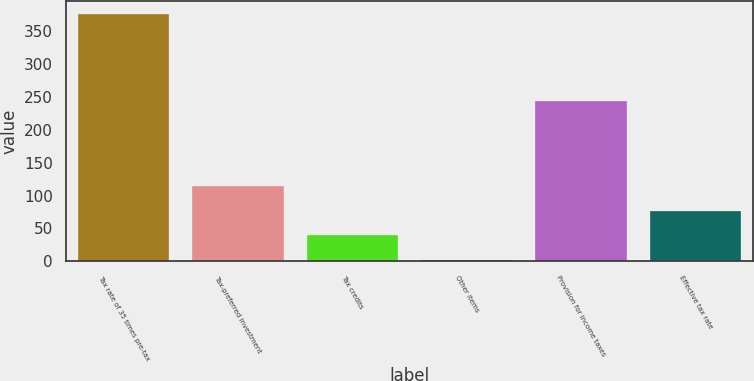Convert chart to OTSL. <chart><loc_0><loc_0><loc_500><loc_500><bar_chart><fcel>Tax rate of 35 times pre-tax<fcel>Tax-preferred investment<fcel>Tax credits<fcel>Other items<fcel>Provision for income taxes<fcel>Effective tax rate<nl><fcel>376<fcel>114.2<fcel>39.4<fcel>2<fcel>244<fcel>76.8<nl></chart> 